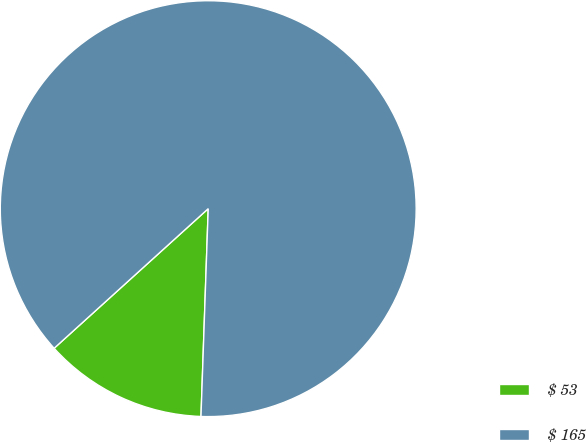Convert chart. <chart><loc_0><loc_0><loc_500><loc_500><pie_chart><fcel>$ 53<fcel>$ 165<nl><fcel>12.73%<fcel>87.27%<nl></chart> 